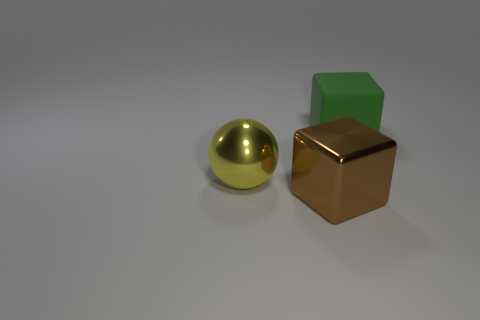Subtract all blue cubes. Subtract all cyan balls. How many cubes are left? 2 Subtract all gray spheres. How many yellow cubes are left? 0 Add 2 large greens. How many things exist? 0 Subtract all big gray cubes. Subtract all green objects. How many objects are left? 2 Add 3 big metal spheres. How many big metal spheres are left? 4 Add 3 large yellow metallic spheres. How many large yellow metallic spheres exist? 4 Add 1 big green matte cubes. How many objects exist? 4 Subtract all brown blocks. How many blocks are left? 1 Subtract 1 brown cubes. How many objects are left? 2 Subtract all cubes. How many objects are left? 1 